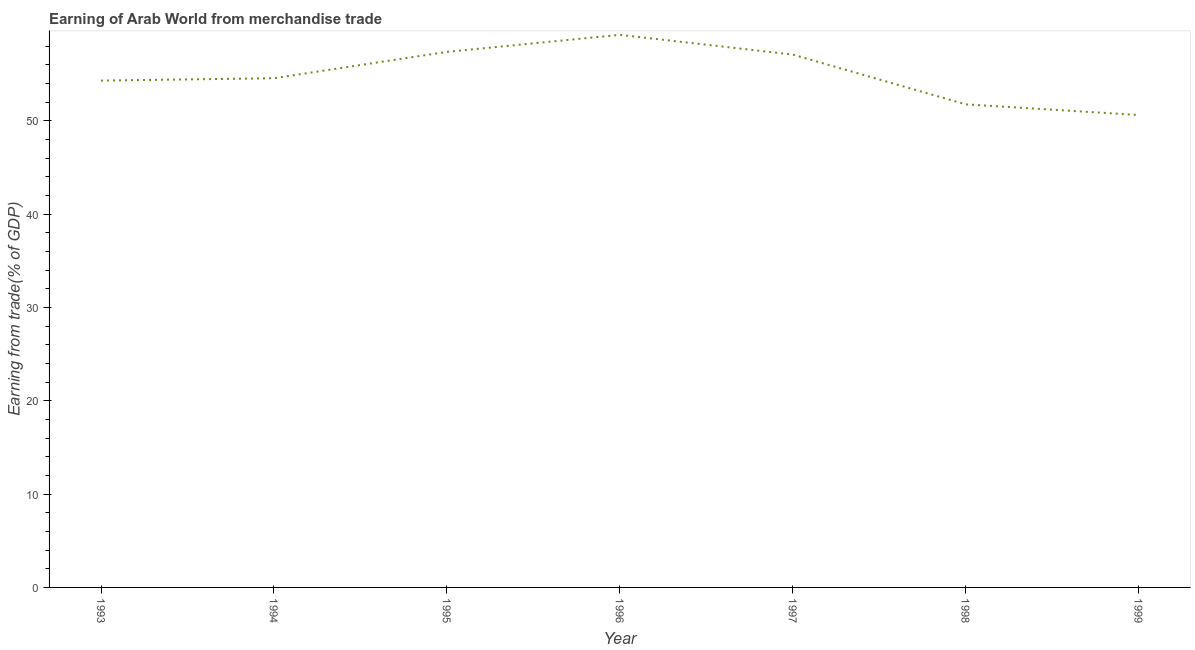What is the earning from merchandise trade in 1997?
Make the answer very short. 57.12. Across all years, what is the maximum earning from merchandise trade?
Keep it short and to the point. 59.23. Across all years, what is the minimum earning from merchandise trade?
Ensure brevity in your answer.  50.64. In which year was the earning from merchandise trade maximum?
Provide a succinct answer. 1996. In which year was the earning from merchandise trade minimum?
Provide a succinct answer. 1999. What is the sum of the earning from merchandise trade?
Ensure brevity in your answer.  385.09. What is the difference between the earning from merchandise trade in 1993 and 1995?
Your answer should be very brief. -3.08. What is the average earning from merchandise trade per year?
Give a very brief answer. 55.01. What is the median earning from merchandise trade?
Provide a succinct answer. 54.58. In how many years, is the earning from merchandise trade greater than 32 %?
Offer a very short reply. 7. What is the ratio of the earning from merchandise trade in 1993 to that in 1997?
Give a very brief answer. 0.95. What is the difference between the highest and the second highest earning from merchandise trade?
Your answer should be compact. 1.83. What is the difference between the highest and the lowest earning from merchandise trade?
Your answer should be compact. 8.59. Does the graph contain grids?
Make the answer very short. No. What is the title of the graph?
Your answer should be very brief. Earning of Arab World from merchandise trade. What is the label or title of the X-axis?
Keep it short and to the point. Year. What is the label or title of the Y-axis?
Offer a terse response. Earning from trade(% of GDP). What is the Earning from trade(% of GDP) of 1993?
Your answer should be compact. 54.33. What is the Earning from trade(% of GDP) of 1994?
Ensure brevity in your answer.  54.58. What is the Earning from trade(% of GDP) of 1995?
Offer a terse response. 57.41. What is the Earning from trade(% of GDP) in 1996?
Provide a short and direct response. 59.23. What is the Earning from trade(% of GDP) in 1997?
Make the answer very short. 57.12. What is the Earning from trade(% of GDP) in 1998?
Offer a very short reply. 51.78. What is the Earning from trade(% of GDP) of 1999?
Your response must be concise. 50.64. What is the difference between the Earning from trade(% of GDP) in 1993 and 1994?
Your answer should be compact. -0.25. What is the difference between the Earning from trade(% of GDP) in 1993 and 1995?
Keep it short and to the point. -3.08. What is the difference between the Earning from trade(% of GDP) in 1993 and 1996?
Provide a short and direct response. -4.9. What is the difference between the Earning from trade(% of GDP) in 1993 and 1997?
Your answer should be very brief. -2.79. What is the difference between the Earning from trade(% of GDP) in 1993 and 1998?
Provide a short and direct response. 2.55. What is the difference between the Earning from trade(% of GDP) in 1993 and 1999?
Your answer should be very brief. 3.69. What is the difference between the Earning from trade(% of GDP) in 1994 and 1995?
Ensure brevity in your answer.  -2.83. What is the difference between the Earning from trade(% of GDP) in 1994 and 1996?
Your answer should be very brief. -4.65. What is the difference between the Earning from trade(% of GDP) in 1994 and 1997?
Provide a short and direct response. -2.53. What is the difference between the Earning from trade(% of GDP) in 1994 and 1998?
Keep it short and to the point. 2.8. What is the difference between the Earning from trade(% of GDP) in 1994 and 1999?
Offer a very short reply. 3.94. What is the difference between the Earning from trade(% of GDP) in 1995 and 1996?
Ensure brevity in your answer.  -1.83. What is the difference between the Earning from trade(% of GDP) in 1995 and 1997?
Provide a short and direct response. 0.29. What is the difference between the Earning from trade(% of GDP) in 1995 and 1998?
Make the answer very short. 5.62. What is the difference between the Earning from trade(% of GDP) in 1995 and 1999?
Make the answer very short. 6.77. What is the difference between the Earning from trade(% of GDP) in 1996 and 1997?
Provide a short and direct response. 2.12. What is the difference between the Earning from trade(% of GDP) in 1996 and 1998?
Your response must be concise. 7.45. What is the difference between the Earning from trade(% of GDP) in 1996 and 1999?
Give a very brief answer. 8.59. What is the difference between the Earning from trade(% of GDP) in 1997 and 1998?
Provide a short and direct response. 5.33. What is the difference between the Earning from trade(% of GDP) in 1997 and 1999?
Your answer should be compact. 6.48. What is the difference between the Earning from trade(% of GDP) in 1998 and 1999?
Provide a short and direct response. 1.14. What is the ratio of the Earning from trade(% of GDP) in 1993 to that in 1995?
Keep it short and to the point. 0.95. What is the ratio of the Earning from trade(% of GDP) in 1993 to that in 1996?
Offer a terse response. 0.92. What is the ratio of the Earning from trade(% of GDP) in 1993 to that in 1997?
Provide a short and direct response. 0.95. What is the ratio of the Earning from trade(% of GDP) in 1993 to that in 1998?
Ensure brevity in your answer.  1.05. What is the ratio of the Earning from trade(% of GDP) in 1993 to that in 1999?
Ensure brevity in your answer.  1.07. What is the ratio of the Earning from trade(% of GDP) in 1994 to that in 1995?
Offer a terse response. 0.95. What is the ratio of the Earning from trade(% of GDP) in 1994 to that in 1996?
Your response must be concise. 0.92. What is the ratio of the Earning from trade(% of GDP) in 1994 to that in 1997?
Provide a succinct answer. 0.96. What is the ratio of the Earning from trade(% of GDP) in 1994 to that in 1998?
Your answer should be compact. 1.05. What is the ratio of the Earning from trade(% of GDP) in 1994 to that in 1999?
Keep it short and to the point. 1.08. What is the ratio of the Earning from trade(% of GDP) in 1995 to that in 1997?
Give a very brief answer. 1. What is the ratio of the Earning from trade(% of GDP) in 1995 to that in 1998?
Ensure brevity in your answer.  1.11. What is the ratio of the Earning from trade(% of GDP) in 1995 to that in 1999?
Ensure brevity in your answer.  1.13. What is the ratio of the Earning from trade(% of GDP) in 1996 to that in 1998?
Keep it short and to the point. 1.14. What is the ratio of the Earning from trade(% of GDP) in 1996 to that in 1999?
Give a very brief answer. 1.17. What is the ratio of the Earning from trade(% of GDP) in 1997 to that in 1998?
Your answer should be very brief. 1.1. What is the ratio of the Earning from trade(% of GDP) in 1997 to that in 1999?
Keep it short and to the point. 1.13. 